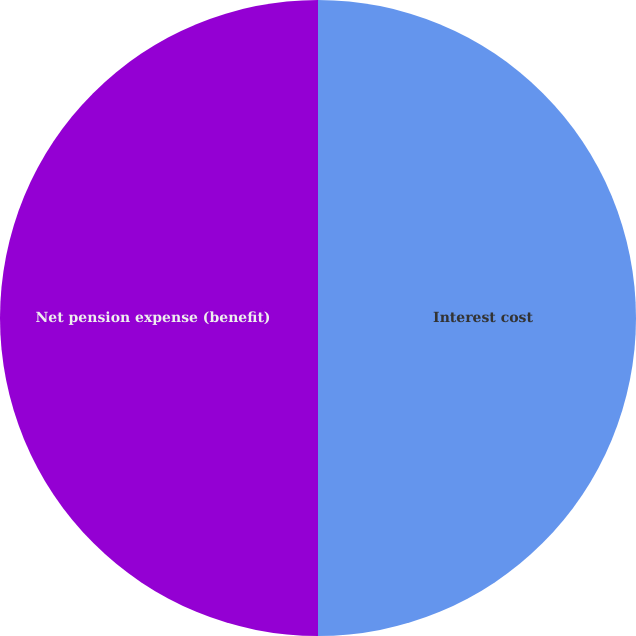Convert chart. <chart><loc_0><loc_0><loc_500><loc_500><pie_chart><fcel>Interest cost<fcel>Net pension expense (benefit)<nl><fcel>50.0%<fcel>50.0%<nl></chart> 